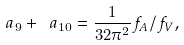<formula> <loc_0><loc_0><loc_500><loc_500>\ a _ { 9 } + \ a _ { 1 0 } = \frac { 1 } { 3 2 \pi ^ { 2 } } f _ { A } / f _ { V } ,</formula> 